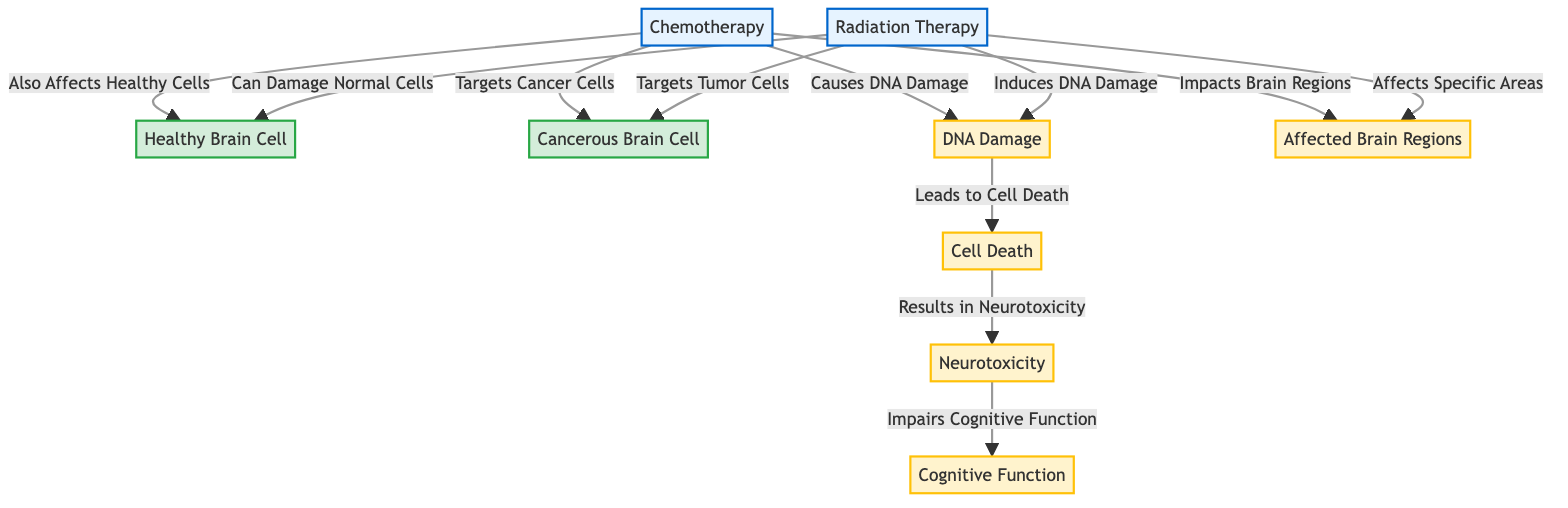What are the two main treatments depicted in the diagram? The diagram shows two treatments: chemotherapy and radiation therapy. These are visually represented with the distinct treatment class, indicating their significance as main components of the infographic.
Answer: chemotherapy and radiation therapy How many types of effects are shown in the diagram? There are four types of effects indicated in the diagram, namely DNA damage, cell death, neurotoxicity, and cognitive function. They are clearly marked and linked to the treatments.
Answer: four Which type of brain cell is primarily targeted by chemotherapy? According to the diagram, chemotherapy primarily targets cancerous brain cells, as indicated by the directed arrow from chemotherapy to the cancer cell node labeled "Targets Cancer Cells."
Answer: cancerous brain cell What effect is caused by DNA damage? The diagram illustrates that DNA damage leads to cell death, establishing a clear cause-and-effect relationship indicated by the connecting arrows.
Answer: Cell Death Which treatment can damage normal cells? The diagram states that radiation therapy can damage normal cells, as indicated by the phrase "Can Damage Normal Cells" linked to the healthy cell node.
Answer: radiation therapy Which brain function is impaired due to neurotoxicity? The diagram shows that neurotoxicity impairs cognitive function, connecting these two effects with an arrow that illustrates the impact from neurotoxicity to cognitive function.
Answer: cognitive function How do both chemotherapy and radiation therapy affect the brain? Both treatments have specific links in the diagram showing that they impact brain regions, demonstrating a direct relationship. This suggests that while targeting cancer, they also affect healthy brain tissue.
Answer: Affected Brain Regions Which process is common to both chemotherapy and radiation therapy? Both treatments lead to DNA damage, shown as a shared effect that arises from the actions of chemotherapy and radiation therapy on the cells.
Answer: DNA Damage 